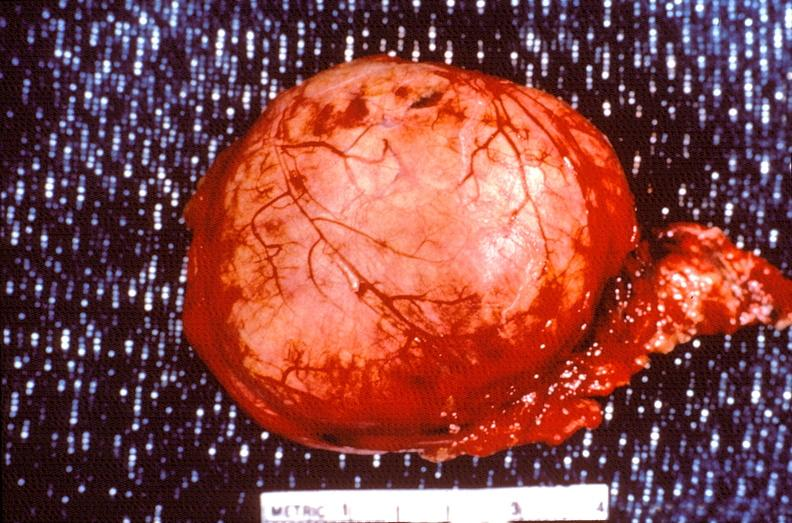s endocrine present?
Answer the question using a single word or phrase. Yes 